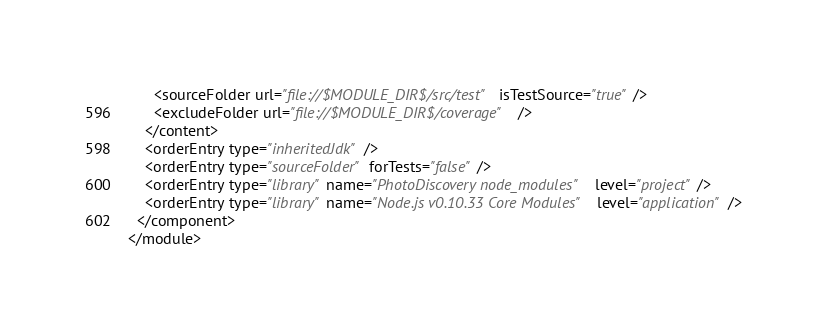Convert code to text. <code><loc_0><loc_0><loc_500><loc_500><_XML_>      <sourceFolder url="file://$MODULE_DIR$/src/test" isTestSource="true" />
      <excludeFolder url="file://$MODULE_DIR$/coverage" />
    </content>
    <orderEntry type="inheritedJdk" />
    <orderEntry type="sourceFolder" forTests="false" />
    <orderEntry type="library" name="PhotoDiscovery node_modules" level="project" />
    <orderEntry type="library" name="Node.js v0.10.33 Core Modules" level="application" />
  </component>
</module></code> 